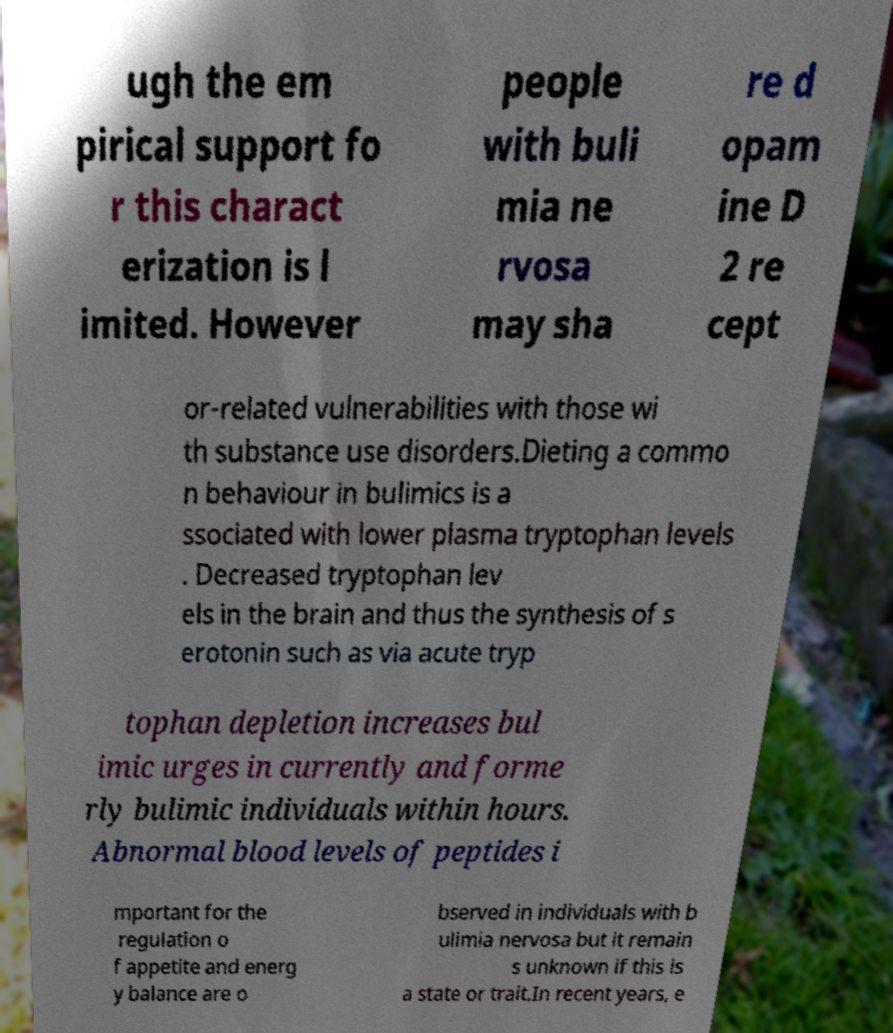Could you assist in decoding the text presented in this image and type it out clearly? ugh the em pirical support fo r this charact erization is l imited. However people with buli mia ne rvosa may sha re d opam ine D 2 re cept or-related vulnerabilities with those wi th substance use disorders.Dieting a commo n behaviour in bulimics is a ssociated with lower plasma tryptophan levels . Decreased tryptophan lev els in the brain and thus the synthesis of s erotonin such as via acute tryp tophan depletion increases bul imic urges in currently and forme rly bulimic individuals within hours. Abnormal blood levels of peptides i mportant for the regulation o f appetite and energ y balance are o bserved in individuals with b ulimia nervosa but it remain s unknown if this is a state or trait.In recent years, e 